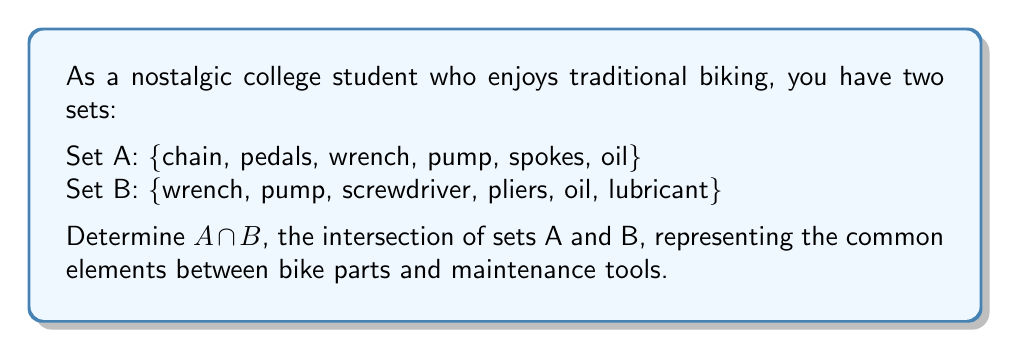Can you answer this question? To find the intersection of sets A and B, we need to identify the elements that are present in both sets. Let's go through this step-by-step:

1. First, let's list out the elements of each set:
   Set A: {chain, pedals, wrench, pump, spokes, oil}
   Set B: {wrench, pump, screwdriver, pliers, oil, lubricant}

2. Now, we'll compare each element in Set A with the elements in Set B:

   - chain: not in Set B
   - pedals: not in Set B
   - wrench: in Set B
   - pump: in Set B
   - spokes: not in Set B
   - oil: in Set B

3. The elements that appear in both sets are: wrench, pump, and oil.

4. Therefore, the intersection of A and B, denoted as $A \cap B$, contains these common elements.

In set notation, we write this as:

$$A \cap B = \{wrench, pump, oil\}$$

This intersection represents the items that are both bike parts (or closely related to bikes) and maintenance tools, fitting well with the theme of traditional biking and its maintenance.
Answer: $A \cap B = \{wrench, pump, oil\}$ 